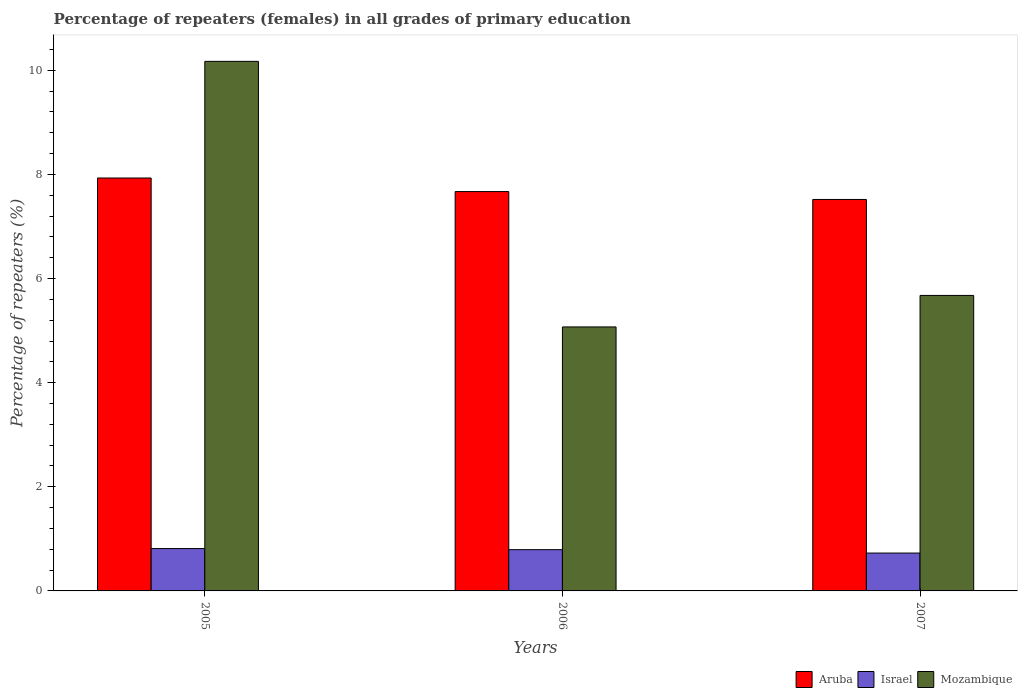How many groups of bars are there?
Provide a short and direct response. 3. Are the number of bars on each tick of the X-axis equal?
Give a very brief answer. Yes. How many bars are there on the 1st tick from the right?
Provide a short and direct response. 3. What is the label of the 1st group of bars from the left?
Offer a terse response. 2005. What is the percentage of repeaters (females) in Aruba in 2006?
Keep it short and to the point. 7.67. Across all years, what is the maximum percentage of repeaters (females) in Israel?
Your response must be concise. 0.81. Across all years, what is the minimum percentage of repeaters (females) in Aruba?
Your answer should be very brief. 7.52. What is the total percentage of repeaters (females) in Mozambique in the graph?
Offer a terse response. 20.92. What is the difference between the percentage of repeaters (females) in Israel in 2005 and that in 2007?
Make the answer very short. 0.09. What is the difference between the percentage of repeaters (females) in Mozambique in 2007 and the percentage of repeaters (females) in Aruba in 2005?
Offer a terse response. -2.26. What is the average percentage of repeaters (females) in Israel per year?
Your response must be concise. 0.78. In the year 2006, what is the difference between the percentage of repeaters (females) in Aruba and percentage of repeaters (females) in Israel?
Provide a succinct answer. 6.88. In how many years, is the percentage of repeaters (females) in Israel greater than 5.6 %?
Your response must be concise. 0. What is the ratio of the percentage of repeaters (females) in Israel in 2006 to that in 2007?
Provide a succinct answer. 1.09. What is the difference between the highest and the second highest percentage of repeaters (females) in Aruba?
Offer a terse response. 0.26. What is the difference between the highest and the lowest percentage of repeaters (females) in Mozambique?
Provide a short and direct response. 5.1. Is the sum of the percentage of repeaters (females) in Israel in 2005 and 2006 greater than the maximum percentage of repeaters (females) in Mozambique across all years?
Keep it short and to the point. No. What does the 3rd bar from the left in 2006 represents?
Ensure brevity in your answer.  Mozambique. What does the 1st bar from the right in 2005 represents?
Ensure brevity in your answer.  Mozambique. How many bars are there?
Offer a terse response. 9. How many years are there in the graph?
Offer a terse response. 3. Are the values on the major ticks of Y-axis written in scientific E-notation?
Ensure brevity in your answer.  No. Does the graph contain any zero values?
Your answer should be compact. No. Does the graph contain grids?
Make the answer very short. No. Where does the legend appear in the graph?
Offer a very short reply. Bottom right. What is the title of the graph?
Keep it short and to the point. Percentage of repeaters (females) in all grades of primary education. Does "Angola" appear as one of the legend labels in the graph?
Make the answer very short. No. What is the label or title of the Y-axis?
Offer a very short reply. Percentage of repeaters (%). What is the Percentage of repeaters (%) of Aruba in 2005?
Your answer should be very brief. 7.93. What is the Percentage of repeaters (%) of Israel in 2005?
Ensure brevity in your answer.  0.81. What is the Percentage of repeaters (%) in Mozambique in 2005?
Offer a very short reply. 10.17. What is the Percentage of repeaters (%) of Aruba in 2006?
Make the answer very short. 7.67. What is the Percentage of repeaters (%) in Israel in 2006?
Keep it short and to the point. 0.79. What is the Percentage of repeaters (%) in Mozambique in 2006?
Your answer should be compact. 5.07. What is the Percentage of repeaters (%) in Aruba in 2007?
Provide a succinct answer. 7.52. What is the Percentage of repeaters (%) of Israel in 2007?
Make the answer very short. 0.73. What is the Percentage of repeaters (%) of Mozambique in 2007?
Your answer should be compact. 5.68. Across all years, what is the maximum Percentage of repeaters (%) in Aruba?
Offer a terse response. 7.93. Across all years, what is the maximum Percentage of repeaters (%) of Israel?
Your response must be concise. 0.81. Across all years, what is the maximum Percentage of repeaters (%) of Mozambique?
Make the answer very short. 10.17. Across all years, what is the minimum Percentage of repeaters (%) in Aruba?
Give a very brief answer. 7.52. Across all years, what is the minimum Percentage of repeaters (%) of Israel?
Your answer should be compact. 0.73. Across all years, what is the minimum Percentage of repeaters (%) of Mozambique?
Provide a succinct answer. 5.07. What is the total Percentage of repeaters (%) of Aruba in the graph?
Ensure brevity in your answer.  23.12. What is the total Percentage of repeaters (%) of Israel in the graph?
Provide a succinct answer. 2.33. What is the total Percentage of repeaters (%) in Mozambique in the graph?
Your response must be concise. 20.92. What is the difference between the Percentage of repeaters (%) in Aruba in 2005 and that in 2006?
Offer a terse response. 0.26. What is the difference between the Percentage of repeaters (%) in Israel in 2005 and that in 2006?
Provide a succinct answer. 0.02. What is the difference between the Percentage of repeaters (%) of Mozambique in 2005 and that in 2006?
Make the answer very short. 5.1. What is the difference between the Percentage of repeaters (%) in Aruba in 2005 and that in 2007?
Give a very brief answer. 0.41. What is the difference between the Percentage of repeaters (%) in Israel in 2005 and that in 2007?
Your response must be concise. 0.09. What is the difference between the Percentage of repeaters (%) of Mozambique in 2005 and that in 2007?
Offer a terse response. 4.5. What is the difference between the Percentage of repeaters (%) of Aruba in 2006 and that in 2007?
Your response must be concise. 0.15. What is the difference between the Percentage of repeaters (%) in Israel in 2006 and that in 2007?
Ensure brevity in your answer.  0.07. What is the difference between the Percentage of repeaters (%) of Mozambique in 2006 and that in 2007?
Provide a succinct answer. -0.61. What is the difference between the Percentage of repeaters (%) of Aruba in 2005 and the Percentage of repeaters (%) of Israel in 2006?
Offer a very short reply. 7.14. What is the difference between the Percentage of repeaters (%) in Aruba in 2005 and the Percentage of repeaters (%) in Mozambique in 2006?
Your response must be concise. 2.86. What is the difference between the Percentage of repeaters (%) in Israel in 2005 and the Percentage of repeaters (%) in Mozambique in 2006?
Give a very brief answer. -4.26. What is the difference between the Percentage of repeaters (%) in Aruba in 2005 and the Percentage of repeaters (%) in Israel in 2007?
Your response must be concise. 7.2. What is the difference between the Percentage of repeaters (%) in Aruba in 2005 and the Percentage of repeaters (%) in Mozambique in 2007?
Your answer should be compact. 2.26. What is the difference between the Percentage of repeaters (%) in Israel in 2005 and the Percentage of repeaters (%) in Mozambique in 2007?
Provide a short and direct response. -4.86. What is the difference between the Percentage of repeaters (%) in Aruba in 2006 and the Percentage of repeaters (%) in Israel in 2007?
Ensure brevity in your answer.  6.94. What is the difference between the Percentage of repeaters (%) of Aruba in 2006 and the Percentage of repeaters (%) of Mozambique in 2007?
Offer a very short reply. 2. What is the difference between the Percentage of repeaters (%) of Israel in 2006 and the Percentage of repeaters (%) of Mozambique in 2007?
Give a very brief answer. -4.88. What is the average Percentage of repeaters (%) in Aruba per year?
Give a very brief answer. 7.71. What is the average Percentage of repeaters (%) of Mozambique per year?
Offer a very short reply. 6.97. In the year 2005, what is the difference between the Percentage of repeaters (%) of Aruba and Percentage of repeaters (%) of Israel?
Offer a very short reply. 7.12. In the year 2005, what is the difference between the Percentage of repeaters (%) of Aruba and Percentage of repeaters (%) of Mozambique?
Provide a succinct answer. -2.24. In the year 2005, what is the difference between the Percentage of repeaters (%) in Israel and Percentage of repeaters (%) in Mozambique?
Offer a terse response. -9.36. In the year 2006, what is the difference between the Percentage of repeaters (%) of Aruba and Percentage of repeaters (%) of Israel?
Make the answer very short. 6.88. In the year 2006, what is the difference between the Percentage of repeaters (%) in Aruba and Percentage of repeaters (%) in Mozambique?
Keep it short and to the point. 2.6. In the year 2006, what is the difference between the Percentage of repeaters (%) of Israel and Percentage of repeaters (%) of Mozambique?
Give a very brief answer. -4.28. In the year 2007, what is the difference between the Percentage of repeaters (%) of Aruba and Percentage of repeaters (%) of Israel?
Your answer should be compact. 6.79. In the year 2007, what is the difference between the Percentage of repeaters (%) in Aruba and Percentage of repeaters (%) in Mozambique?
Keep it short and to the point. 1.84. In the year 2007, what is the difference between the Percentage of repeaters (%) of Israel and Percentage of repeaters (%) of Mozambique?
Your response must be concise. -4.95. What is the ratio of the Percentage of repeaters (%) in Aruba in 2005 to that in 2006?
Provide a short and direct response. 1.03. What is the ratio of the Percentage of repeaters (%) in Israel in 2005 to that in 2006?
Make the answer very short. 1.03. What is the ratio of the Percentage of repeaters (%) of Mozambique in 2005 to that in 2006?
Your answer should be very brief. 2.01. What is the ratio of the Percentage of repeaters (%) of Aruba in 2005 to that in 2007?
Ensure brevity in your answer.  1.05. What is the ratio of the Percentage of repeaters (%) of Israel in 2005 to that in 2007?
Offer a terse response. 1.12. What is the ratio of the Percentage of repeaters (%) of Mozambique in 2005 to that in 2007?
Offer a terse response. 1.79. What is the ratio of the Percentage of repeaters (%) in Aruba in 2006 to that in 2007?
Your answer should be very brief. 1.02. What is the ratio of the Percentage of repeaters (%) of Israel in 2006 to that in 2007?
Offer a very short reply. 1.09. What is the ratio of the Percentage of repeaters (%) of Mozambique in 2006 to that in 2007?
Provide a short and direct response. 0.89. What is the difference between the highest and the second highest Percentage of repeaters (%) in Aruba?
Give a very brief answer. 0.26. What is the difference between the highest and the second highest Percentage of repeaters (%) of Israel?
Make the answer very short. 0.02. What is the difference between the highest and the second highest Percentage of repeaters (%) in Mozambique?
Make the answer very short. 4.5. What is the difference between the highest and the lowest Percentage of repeaters (%) of Aruba?
Your response must be concise. 0.41. What is the difference between the highest and the lowest Percentage of repeaters (%) of Israel?
Your response must be concise. 0.09. What is the difference between the highest and the lowest Percentage of repeaters (%) of Mozambique?
Keep it short and to the point. 5.1. 